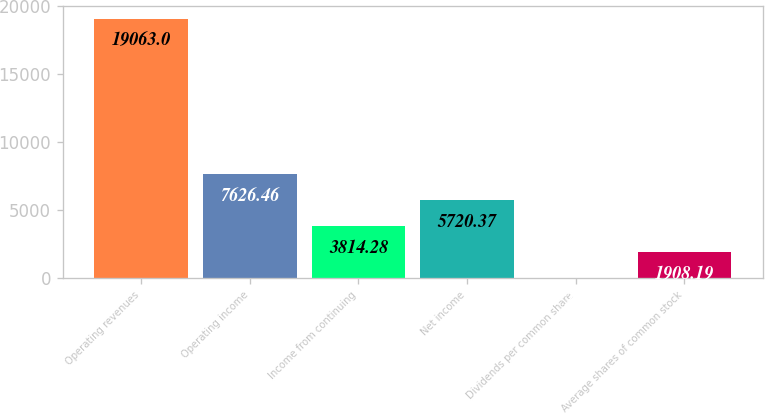Convert chart. <chart><loc_0><loc_0><loc_500><loc_500><bar_chart><fcel>Operating revenues<fcel>Operating income<fcel>Income from continuing<fcel>Net income<fcel>Dividends per common share<fcel>Average shares of common stock<nl><fcel>19063<fcel>7626.46<fcel>3814.28<fcel>5720.37<fcel>2.1<fcel>1908.19<nl></chart> 